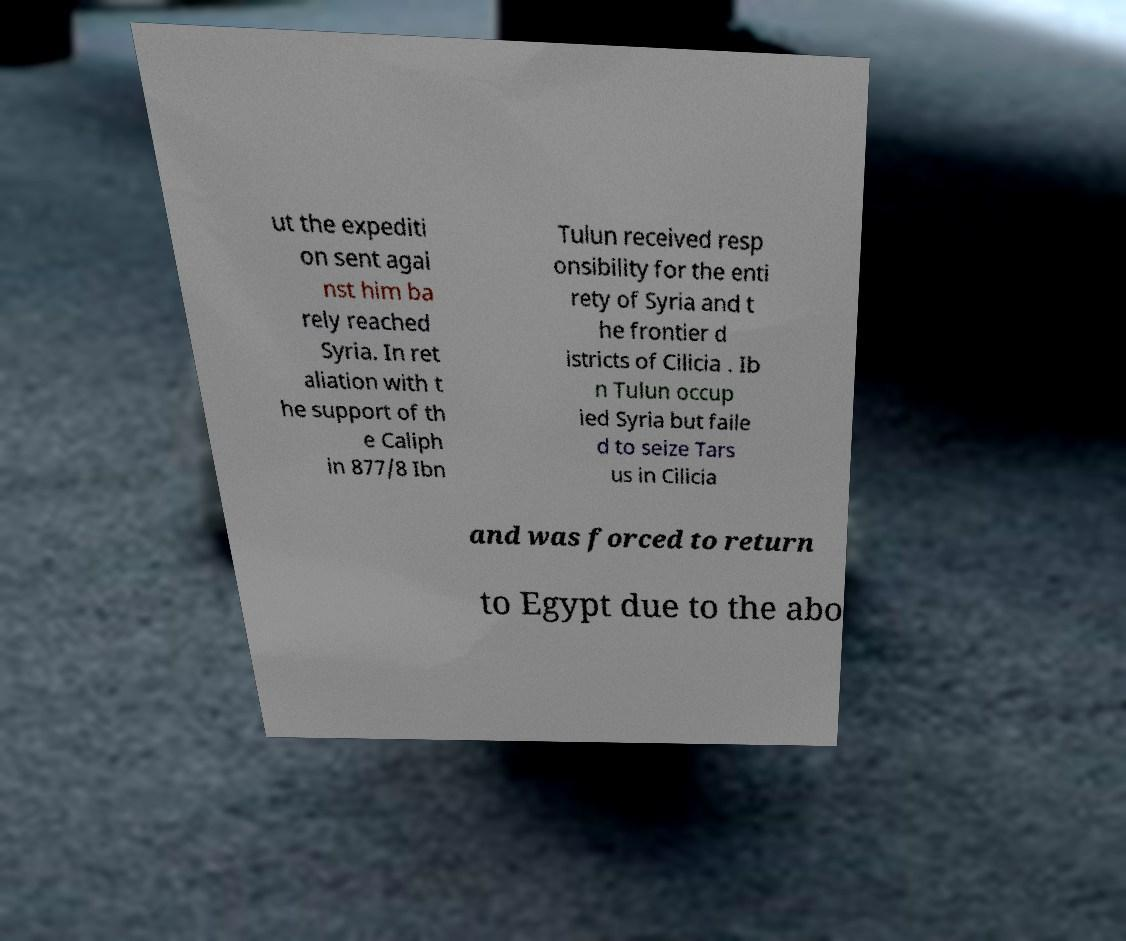Can you read and provide the text displayed in the image?This photo seems to have some interesting text. Can you extract and type it out for me? ut the expediti on sent agai nst him ba rely reached Syria. In ret aliation with t he support of th e Caliph in 877/8 Ibn Tulun received resp onsibility for the enti rety of Syria and t he frontier d istricts of Cilicia . Ib n Tulun occup ied Syria but faile d to seize Tars us in Cilicia and was forced to return to Egypt due to the abo 